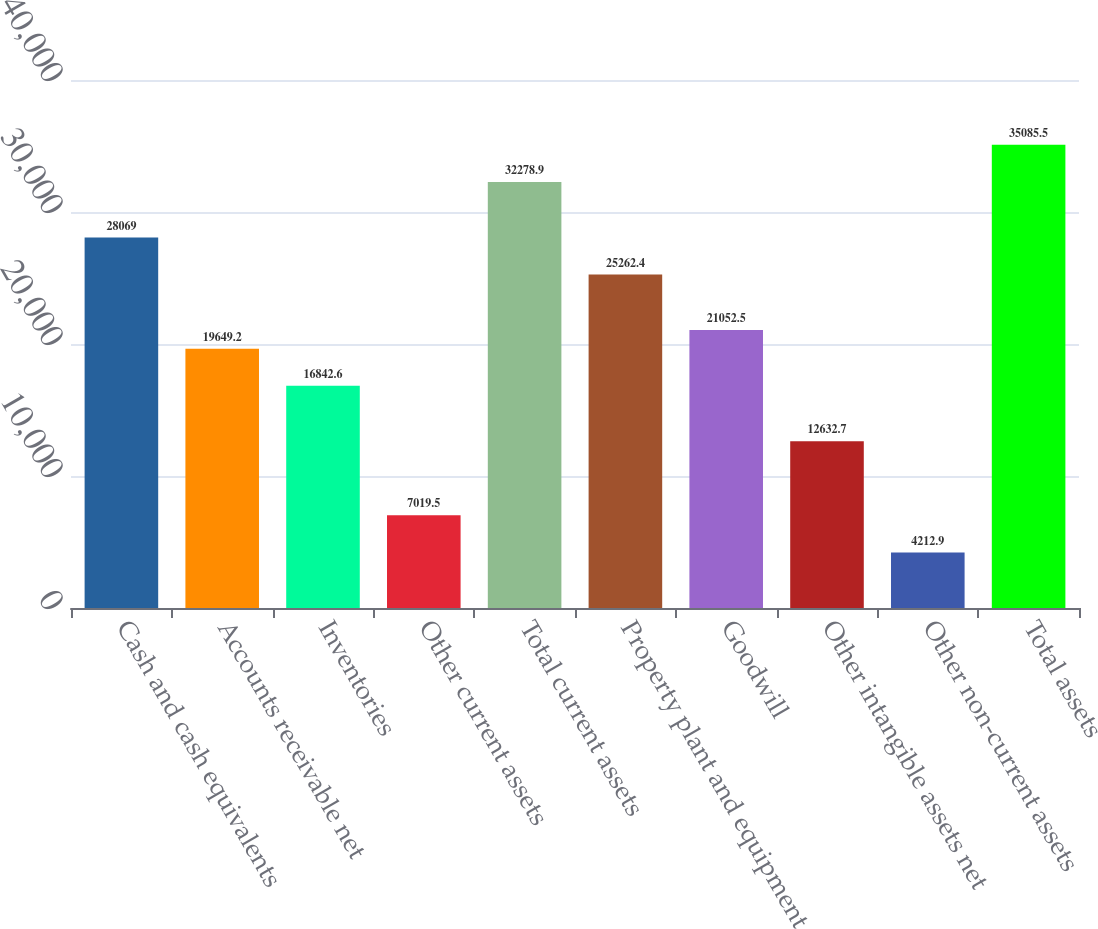Convert chart to OTSL. <chart><loc_0><loc_0><loc_500><loc_500><bar_chart><fcel>Cash and cash equivalents<fcel>Accounts receivable net<fcel>Inventories<fcel>Other current assets<fcel>Total current assets<fcel>Property plant and equipment<fcel>Goodwill<fcel>Other intangible assets net<fcel>Other non-current assets<fcel>Total assets<nl><fcel>28069<fcel>19649.2<fcel>16842.6<fcel>7019.5<fcel>32278.9<fcel>25262.4<fcel>21052.5<fcel>12632.7<fcel>4212.9<fcel>35085.5<nl></chart> 